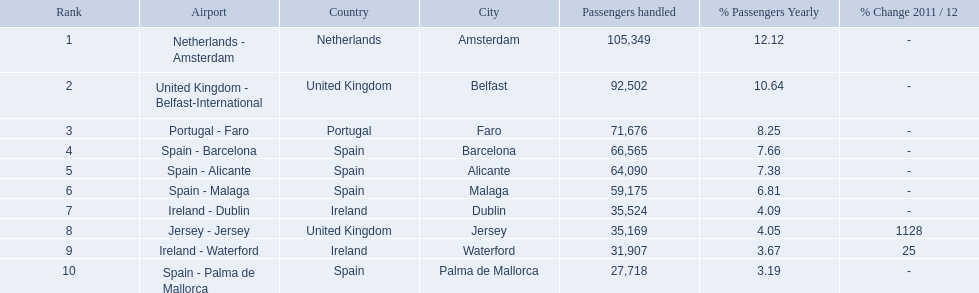Which airports are in europe? Netherlands - Amsterdam, United Kingdom - Belfast-International, Portugal - Faro, Spain - Barcelona, Spain - Alicante, Spain - Malaga, Ireland - Dublin, Ireland - Waterford, Spain - Palma de Mallorca. Which one is from portugal? Portugal - Faro. 